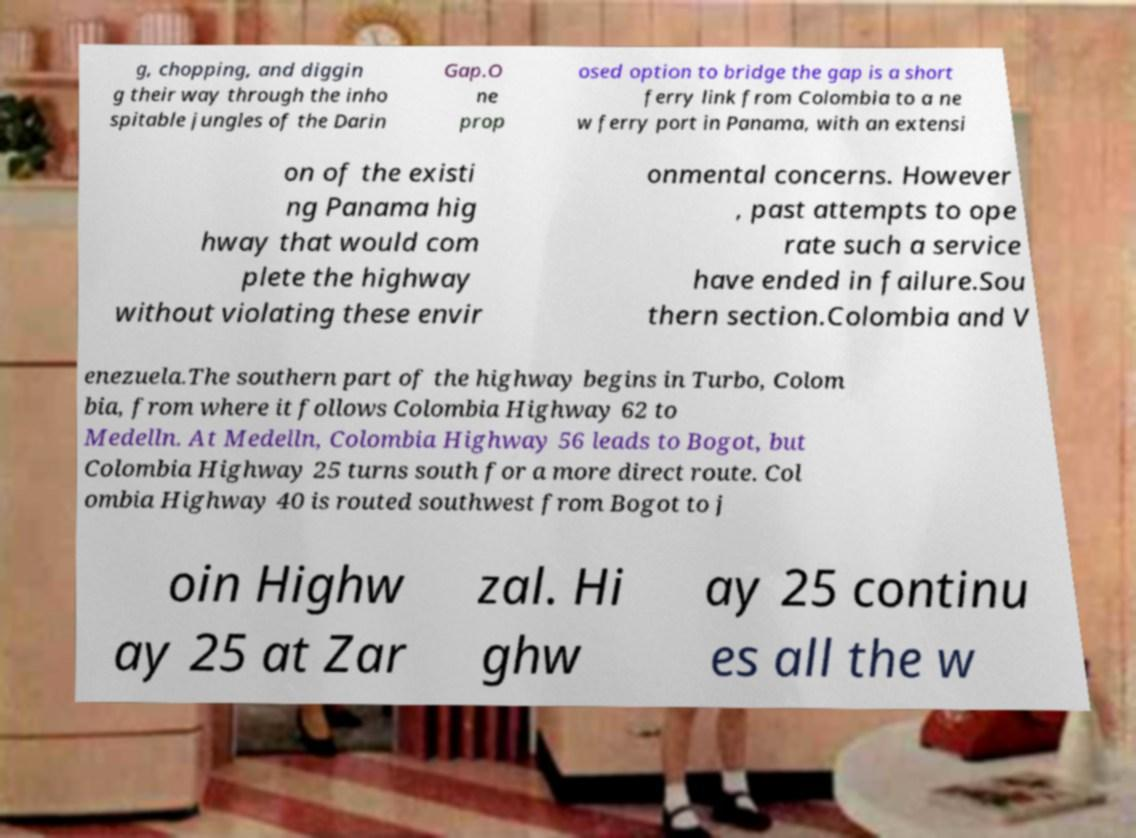Can you accurately transcribe the text from the provided image for me? g, chopping, and diggin g their way through the inho spitable jungles of the Darin Gap.O ne prop osed option to bridge the gap is a short ferry link from Colombia to a ne w ferry port in Panama, with an extensi on of the existi ng Panama hig hway that would com plete the highway without violating these envir onmental concerns. However , past attempts to ope rate such a service have ended in failure.Sou thern section.Colombia and V enezuela.The southern part of the highway begins in Turbo, Colom bia, from where it follows Colombia Highway 62 to Medelln. At Medelln, Colombia Highway 56 leads to Bogot, but Colombia Highway 25 turns south for a more direct route. Col ombia Highway 40 is routed southwest from Bogot to j oin Highw ay 25 at Zar zal. Hi ghw ay 25 continu es all the w 